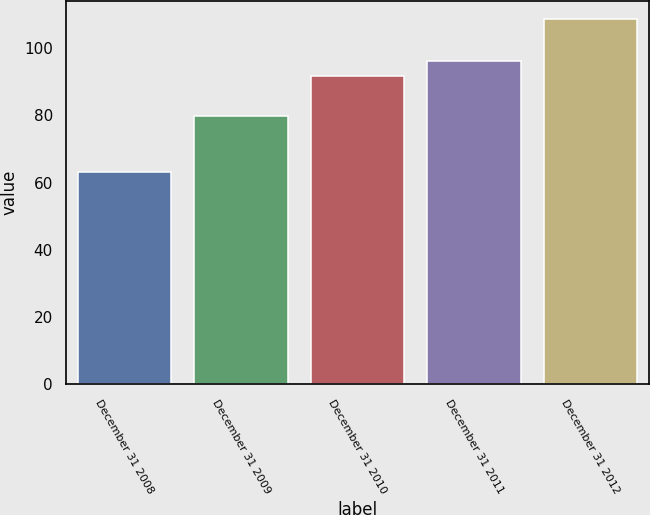Convert chart. <chart><loc_0><loc_0><loc_500><loc_500><bar_chart><fcel>December 31 2008<fcel>December 31 2009<fcel>December 31 2010<fcel>December 31 2011<fcel>December 31 2012<nl><fcel>63<fcel>79.67<fcel>91.67<fcel>96.23<fcel>108.59<nl></chart> 